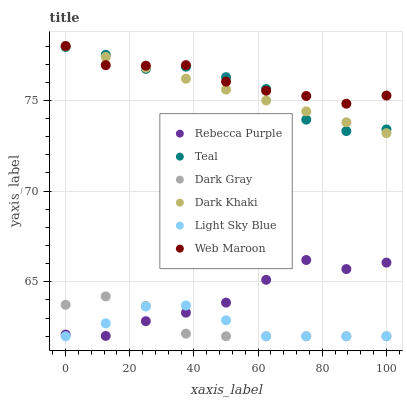Does Dark Gray have the minimum area under the curve?
Answer yes or no. Yes. Does Web Maroon have the maximum area under the curve?
Answer yes or no. Yes. Does Web Maroon have the minimum area under the curve?
Answer yes or no. No. Does Dark Gray have the maximum area under the curve?
Answer yes or no. No. Is Dark Khaki the smoothest?
Answer yes or no. Yes. Is Teal the roughest?
Answer yes or no. Yes. Is Web Maroon the smoothest?
Answer yes or no. No. Is Web Maroon the roughest?
Answer yes or no. No. Does Dark Gray have the lowest value?
Answer yes or no. Yes. Does Web Maroon have the lowest value?
Answer yes or no. No. Does Web Maroon have the highest value?
Answer yes or no. Yes. Does Dark Gray have the highest value?
Answer yes or no. No. Is Dark Gray less than Dark Khaki?
Answer yes or no. Yes. Is Web Maroon greater than Light Sky Blue?
Answer yes or no. Yes. Does Teal intersect Web Maroon?
Answer yes or no. Yes. Is Teal less than Web Maroon?
Answer yes or no. No. Is Teal greater than Web Maroon?
Answer yes or no. No. Does Dark Gray intersect Dark Khaki?
Answer yes or no. No. 